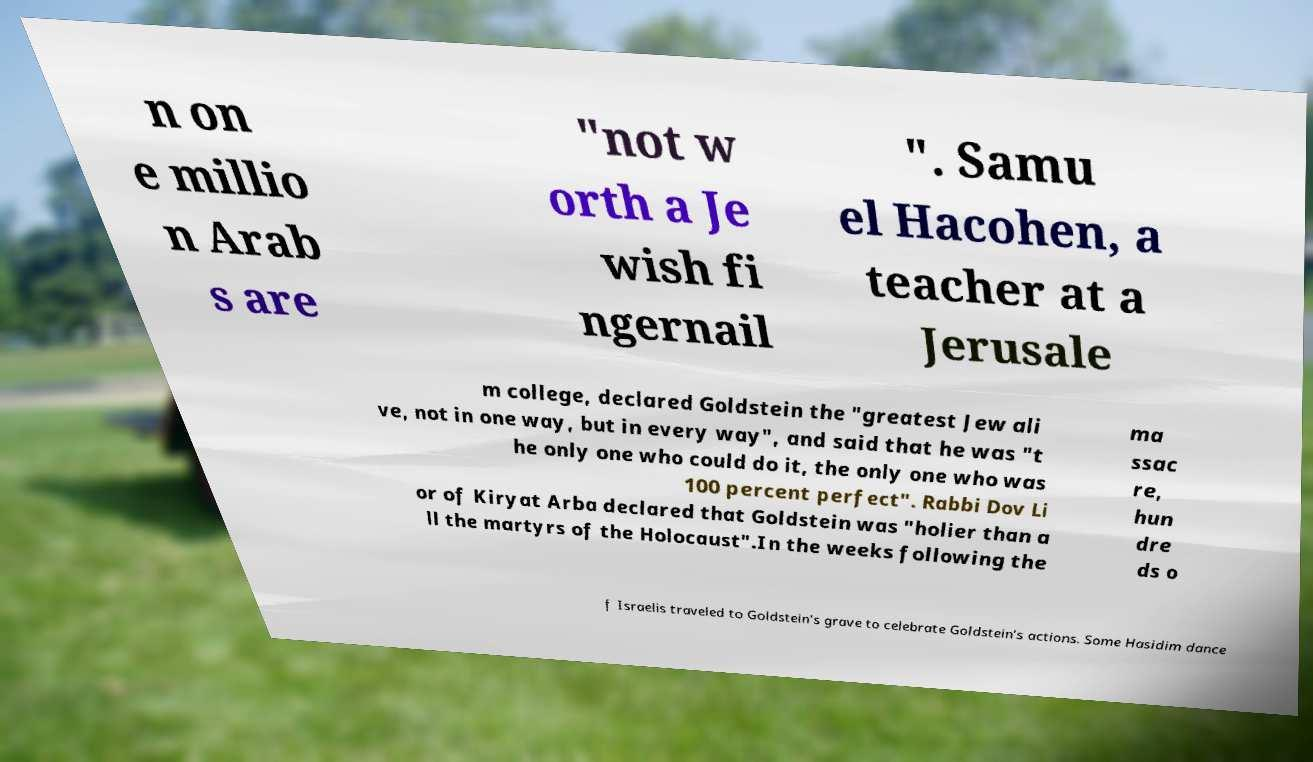Can you read and provide the text displayed in the image?This photo seems to have some interesting text. Can you extract and type it out for me? n on e millio n Arab s are "not w orth a Je wish fi ngernail ". Samu el Hacohen, a teacher at a Jerusale m college, declared Goldstein the "greatest Jew ali ve, not in one way, but in every way", and said that he was "t he only one who could do it, the only one who was 100 percent perfect". Rabbi Dov Li or of Kiryat Arba declared that Goldstein was "holier than a ll the martyrs of the Holocaust".In the weeks following the ma ssac re, hun dre ds o f Israelis traveled to Goldstein's grave to celebrate Goldstein's actions. Some Hasidim dance 